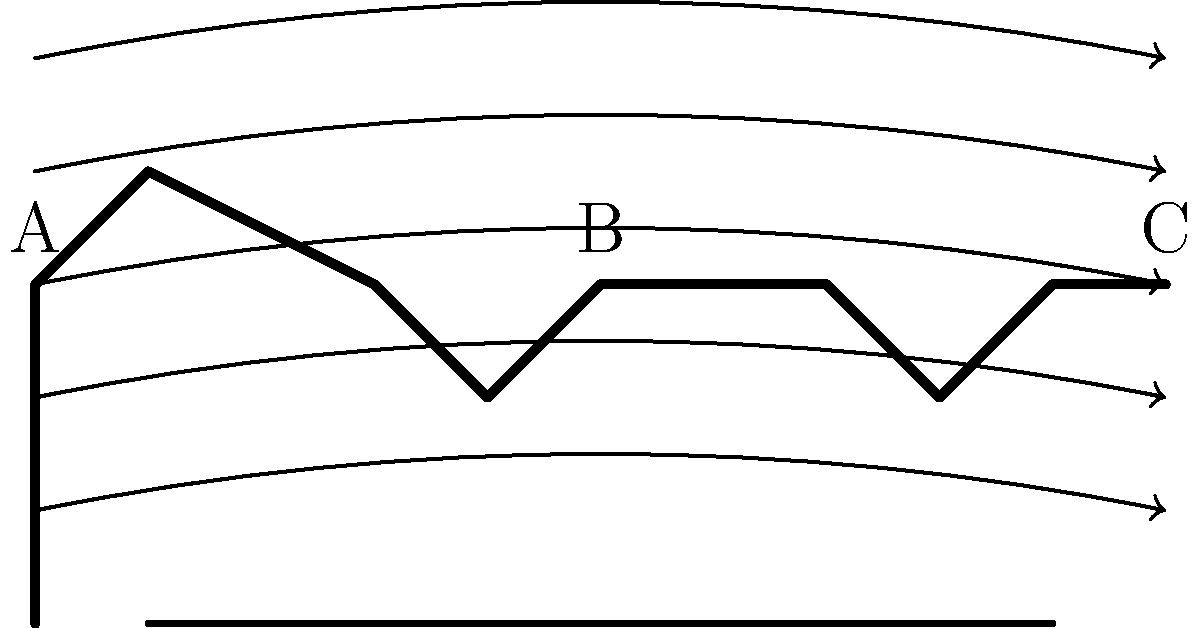In the diagram above, three cycling postures (A, B, and C) are shown with airflow lines. Which posture is likely to result in the least aerodynamic drag? To determine which posture results in the least aerodynamic drag, we need to consider the following factors:

1. Frontal area: A smaller frontal area reduces the surface exposed to the oncoming air, decreasing drag.
2. Streamlining: A more streamlined shape allows air to flow more smoothly around the cyclist, reducing turbulence and drag.

Analyzing the postures:

A) This posture shows an upright position with a large frontal area and poor streamlining.
B) This posture shows a moderate tucked position with a reduced frontal area and improved streamlining compared to A.
C) This posture shows the most aggressive tucked position with the smallest frontal area and best streamlining.

The airflow lines in the diagram indicate smoother air flow around posture C, with less disruption and turbulence. This suggests that posture C creates the least air resistance.

In cycling, the aerodynamic drag force is given by the equation:

$$ F_d = \frac{1}{2} \rho v^2 C_d A $$

Where:
$F_d$ = drag force
$\rho$ = air density
$v$ = velocity
$C_d$ = drag coefficient
$A$ = frontal area

Posture C minimizes both $C_d$ and $A$, resulting in the lowest drag force.
Answer: C 